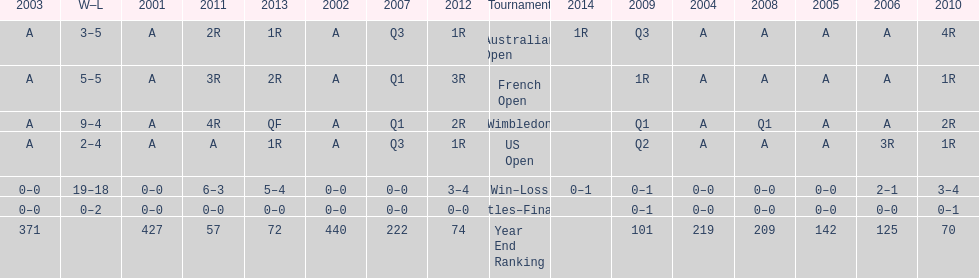What tournament has 5-5 as it's "w-l" record? French Open. 